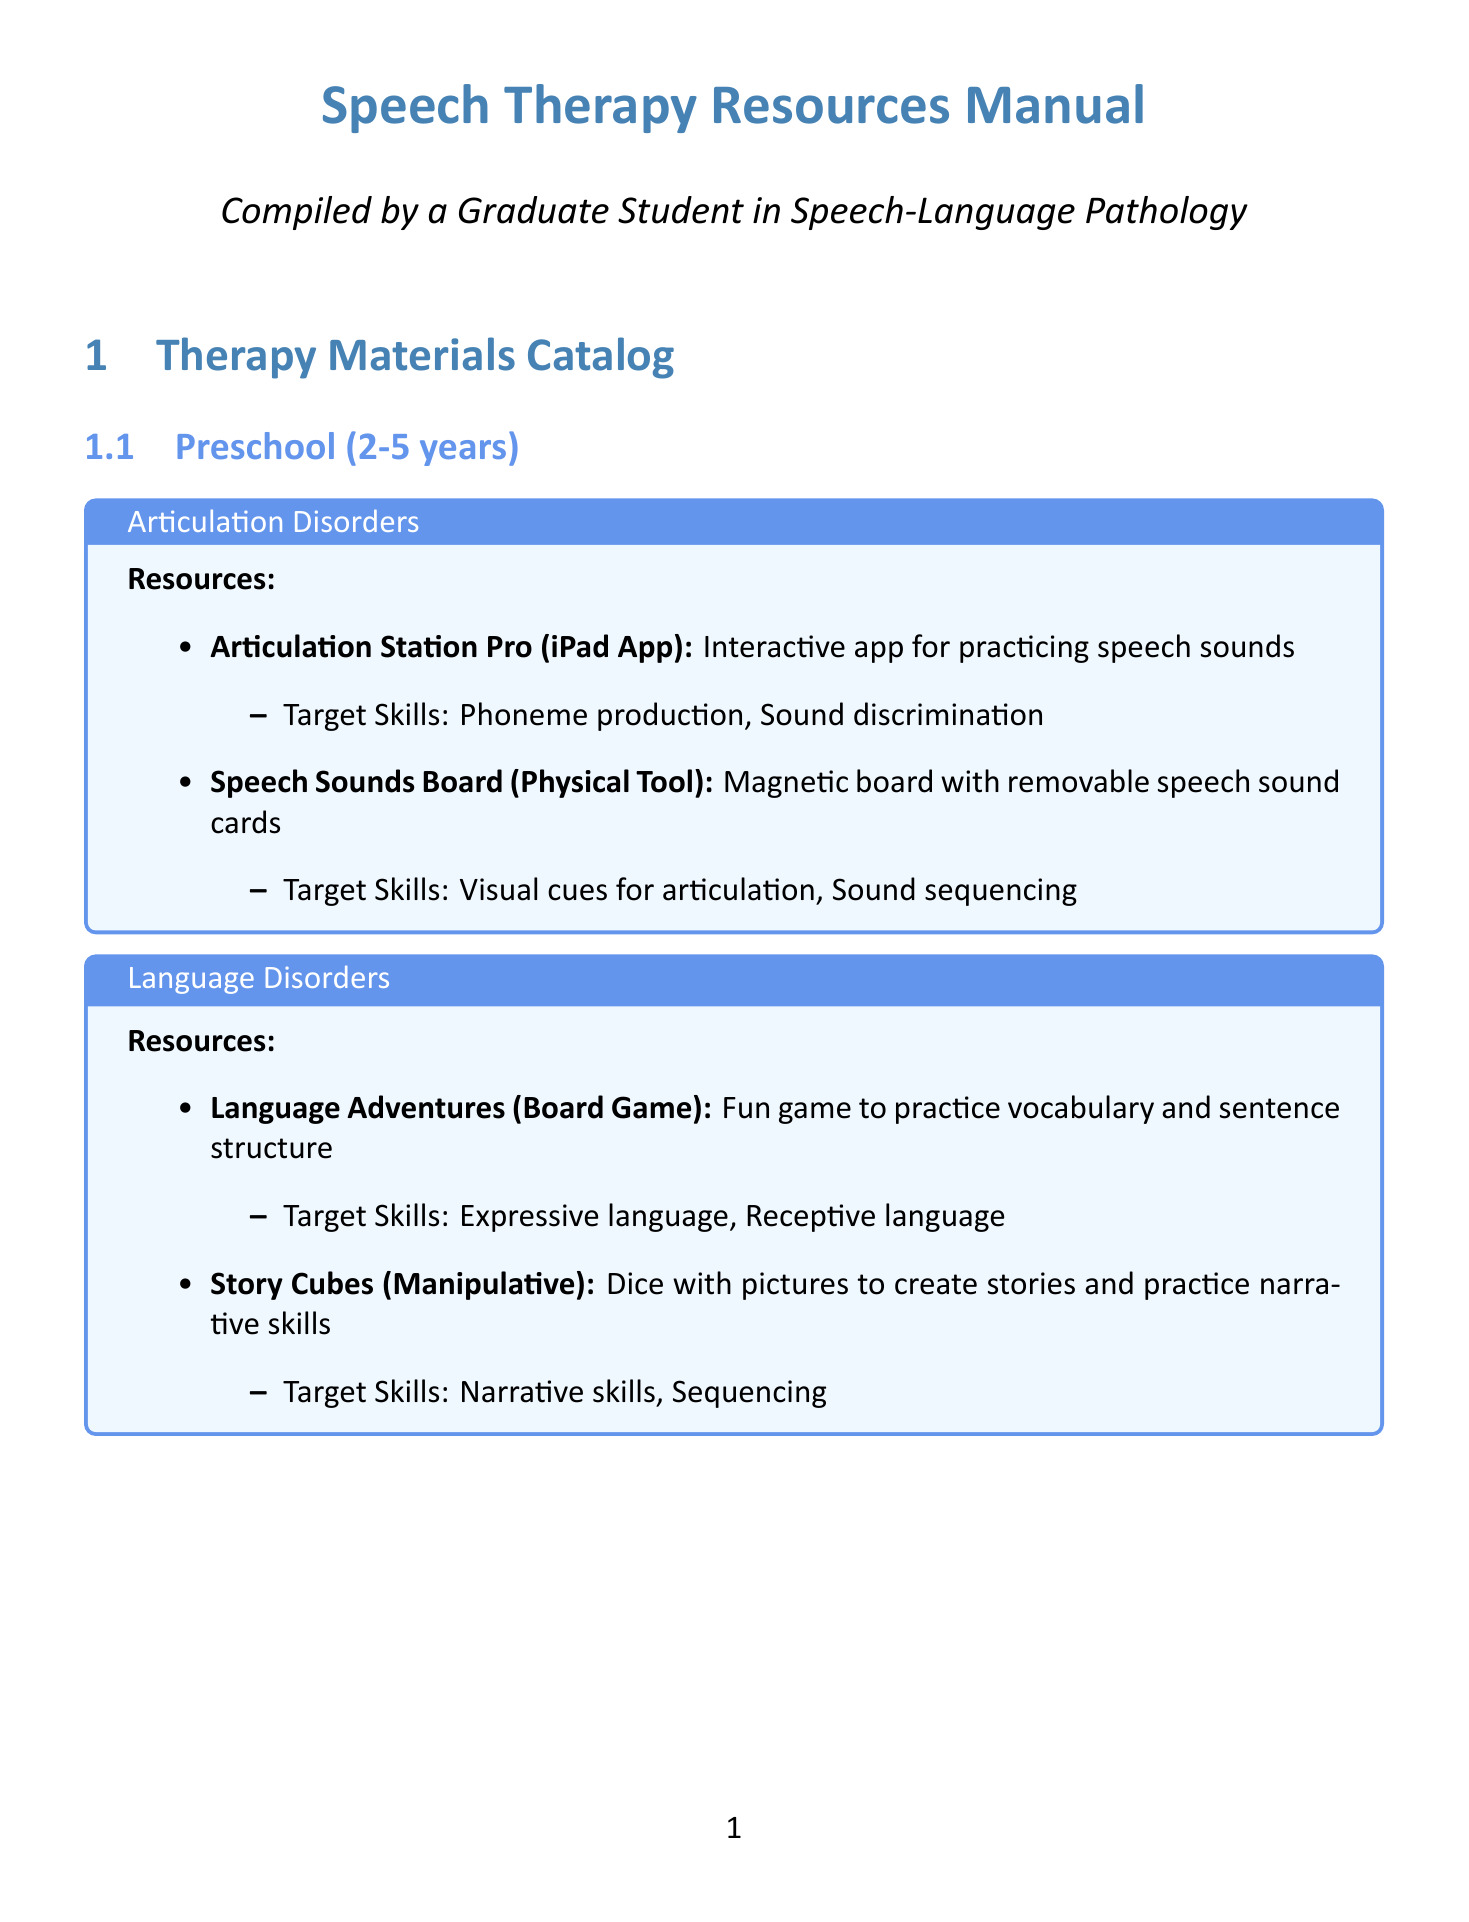what resource is used for studying articulation disorders in preschoolers? The document lists "Articulation Station Pro" and "Speech Sounds Board" as resources for articulation disorders in preschoolers.
Answer: Articulation Station Pro, Speech Sounds Board which assessment tool measures articulation of speech sounds? The document states that the "Goldman-Fristoe Test of Articulation 3 (GFTA-3)" is used for assessing articulation of speech sounds.
Answer: Goldman-Fristoe Test of Articulation 3 (GFTA-3) what age range does the CELF-5 assess? The document indicates that the Clinical Evaluation of Language Fundamentals (CELF-5) assesses ages 5-21 years.
Answer: 5-21 years what type of resource is "Language Adventures"? The document categorizes "Language Adventures" as a board game for practicing vocabulary and sentence structure.
Answer: Board Game how many age groups are listed in the catalog? The document outlines three age groups: Preschool, School-Age, and Adolescents and Adults.
Answer: Three what skills does the DAF Assistant target? According to the document, the DAF Assistant targets fluency control and speech rate modification.
Answer: Fluency control, Speech rate modification which equipment is used for measuring nasalance in speech? The document mentions "Nasometer II 6450" as a device used for measuring nasalance in speech.
Answer: Nasometer II 6450 what is the primary focus of the reference material authored by M.N. Hegde? According to the document, Hegde's PocketGuide focuses on assessment procedures in speech-language pathology.
Answer: Assessment procedures 